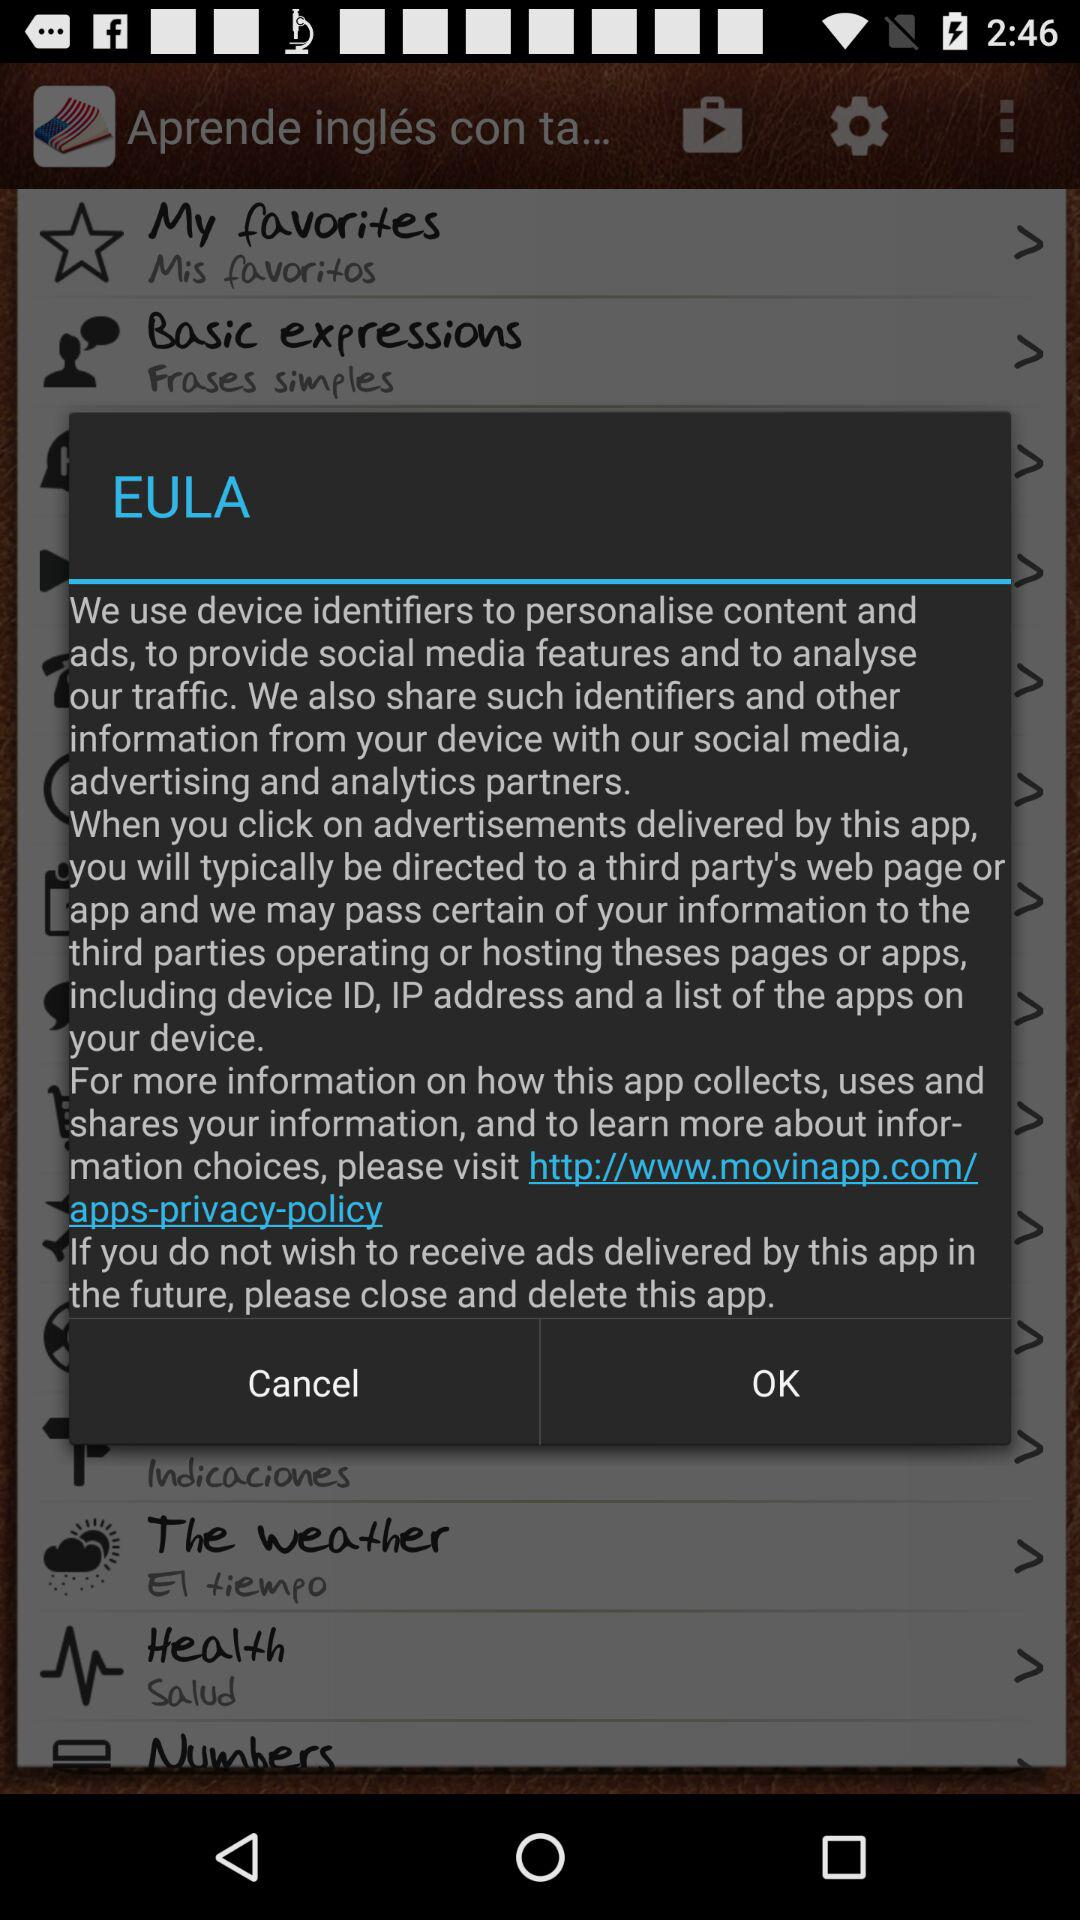What is the URL? The URL is http://www.movieapp.com/apps-privacy-policy. 